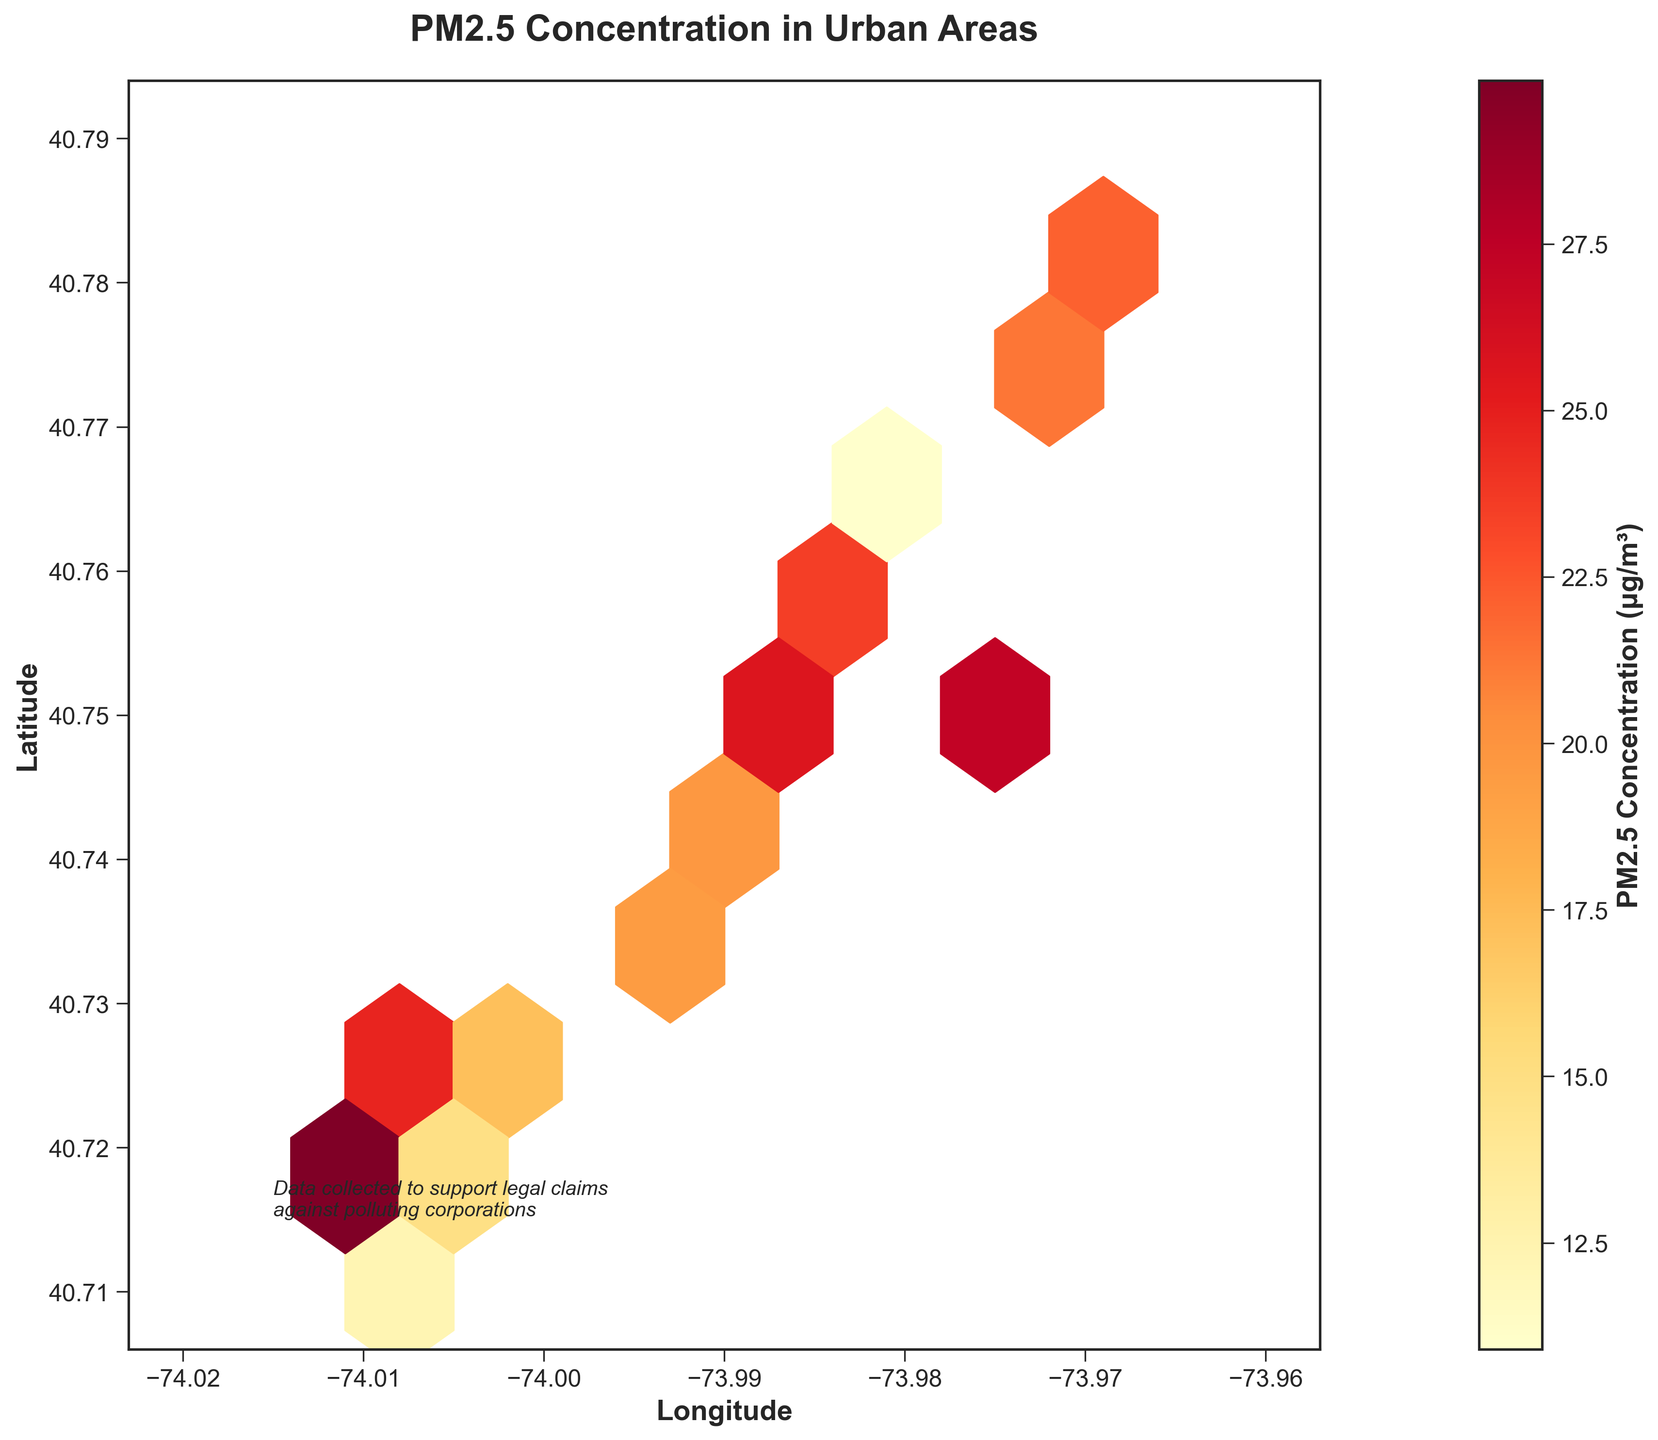What is the title of the plot? The title of the plot is displayed at the top of the figure.
Answer: PM2.5 Concentration in Urban Areas What do the colors on the plot represent? The colors on the plot represent the PM2.5 concentration levels, with a gradient typically ranging from yellow (lower concentration) to red (higher concentration).
Answer: PM2.5 concentration levels How many distinct data points are displayed on the hexbin plot? By counting the number of unique hexagons with varying shades of color, we can find the total number of distinct data points displayed.
Answer: 16 What is the highest PM2.5 concentration level shown in the plot? By examining the color bar's highest value and identifying the hexagon with the corresponding color, we determine the highest concentration level.
Answer: 30.1 μg/m³ Are there more data points with high or low PM2.5 concentration levels? By visually comparing the number of hexagons with darker colors (representing high concentration levels) to those with lighter colors (representing low concentration levels), we can determine which is more prevalent.
Answer: More data points with high concentration levels Which area has the highest concentration of PM2.5, and during which time was it recorded? By identifying the darkest hexagon in the plot and cross-referencing its location with the data's latitude and longitude, we can determine the specific area and the recorded time.
Answer: Near (40.7169, -74.0134) at 18:00 How does the PM2.5 concentration at 06:00 compare to the concentration at 18:00? By looking at the colors of the hexagons corresponding to the times 06:00 and 18:00, we see a lighter hexagon for 06:00 and a much darker one for 18:00.
Answer: 18:00 has a higher concentration What is the average PM2.5 concentration between the hours of 06:00 and 12:30? Sum the PM2.5 concentrations at 06:00, 08:30, 11:15, and 12:30 and divide by the number of data points: (12.3 + 18.7 + 22.1 + 24.7) / 4.
Answer: 19.45 μg/m³ What is the range of longitudes included in the plot? The extent of longitudes displayed in the plot can be determined by the axis labels and the hexbin extent parameters.
Answer: -74.02 to -73.96 Do any locations appear to have consistently higher PM2.5 concentrations throughout the day? By observing which areas have darker or consistently dark-shaded hexagons across different times, we can identify locations with persistently high concentrations.
Answer: Yes, near (40.7169, -74.0134) 